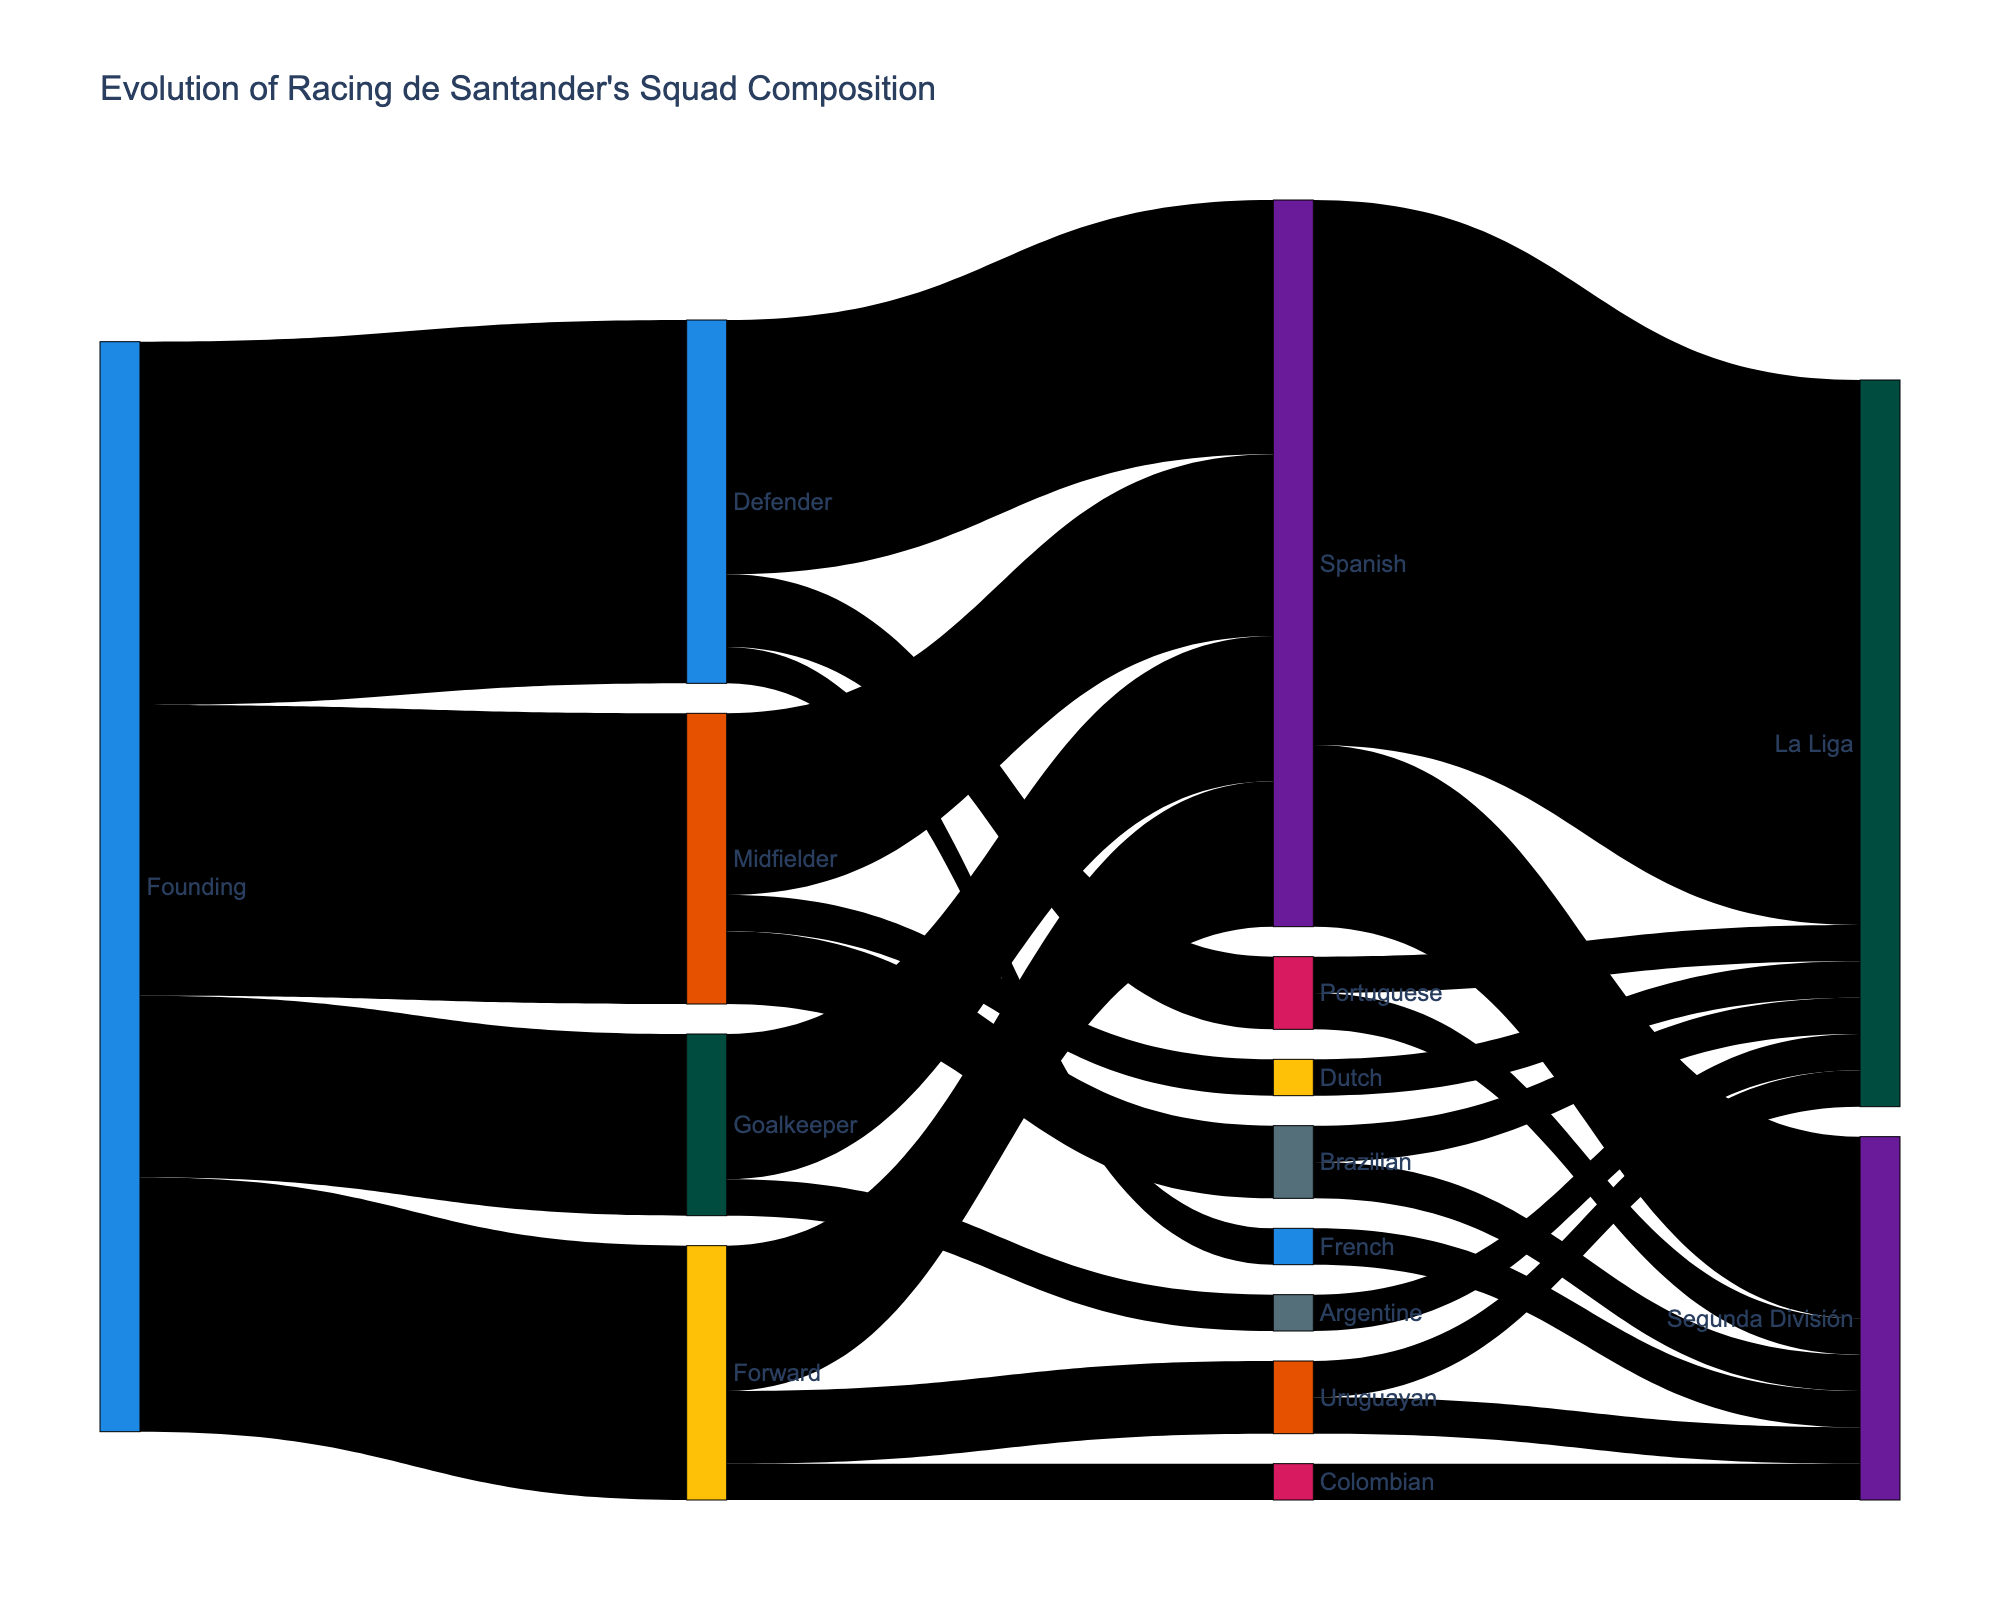What's the title of the plot? Look at the title text displayed prominently above the Sankey Diagram.
Answer: Evolution of Racing de Santander's Squad Composition What are the four main positions displayed in the figure originating from 'Founding'? Observe the initial nodes connected to the 'Founding' label.
Answer: Goalkeeper, Defender, Midfielder, Forward Which nationality has contributed the most Goalkeepers? Identify the node connected from 'Goalkeeper' and compare the widths of connecting lines.
Answer: Spanish How many Midfielders were Brazilian since the club's founding? Check the connection between 'Midfielder' and 'Brazilian' and read the value displayed.
Answer: 2 Which nationality has the least players in 'La Liga'? Look at the nodes leading to 'La Liga' and check the width of the connecting lines to find the smallest one.
Answer: Argentine Comparing Defenders, which nationality had more players, Portuguese or French? Compare the values of the connections from 'Defender' to 'Portuguese' and 'French'.
Answer: Portuguese How many players in total advanced from 'Midfielder' to 'Spanish'? Look at the link between 'Midfielder' and 'Spanish' and read the value.
Answer: 5 Which position has the smallest number of players when the club was founded? Compare the values of the connections originating from 'Founding'.
Answer: Goalkeeper How many players from all positions combined moved to the category 'La Liga'? Sum the values of all connections leading to 'La Liga'.
Answer: 20 Comparing 'Spanish' and 'Segunda División', which has more players, 'Spanish' or all nodes leading to 'Segunda División'? Sum all connections leading to 'Segunda División', then compare it to the 'Spanish' node.
Answer: Spanish 